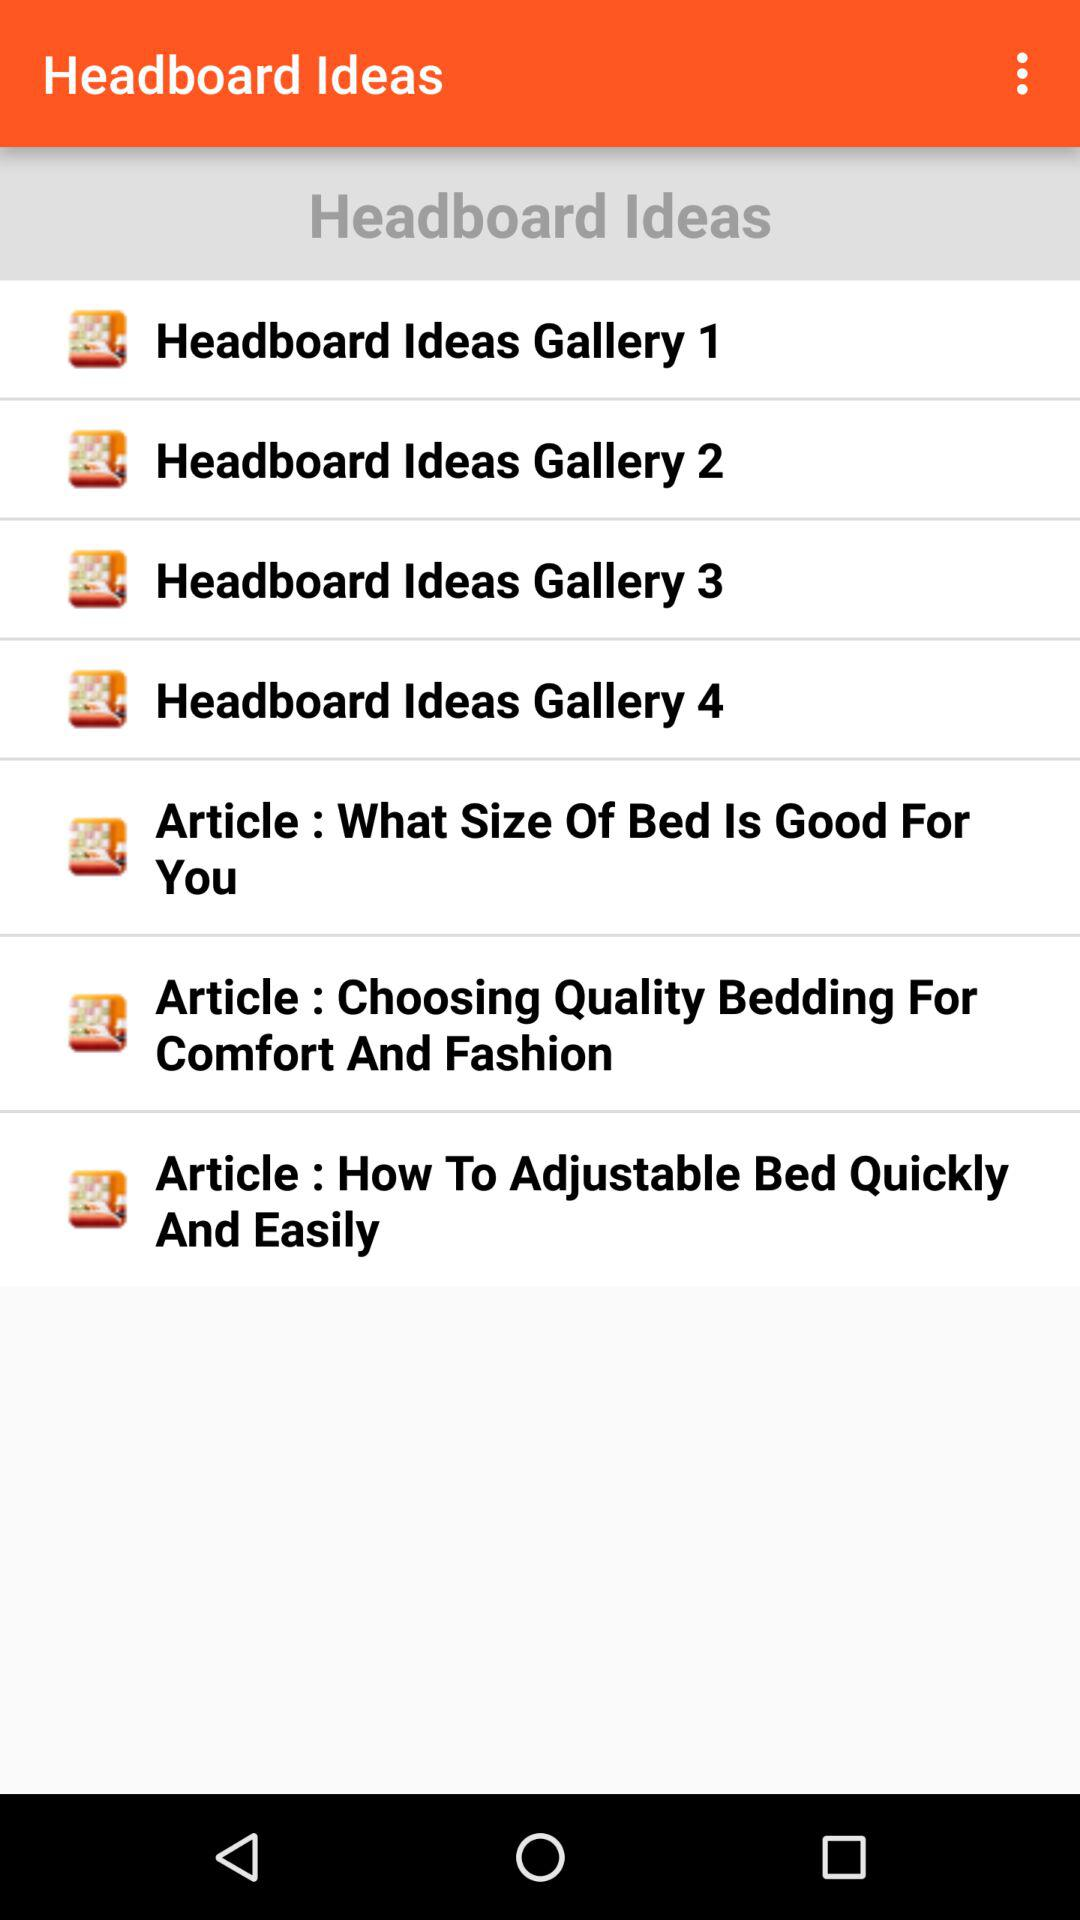How many headboard ideas galleries are there?
Answer the question using a single word or phrase. 4 